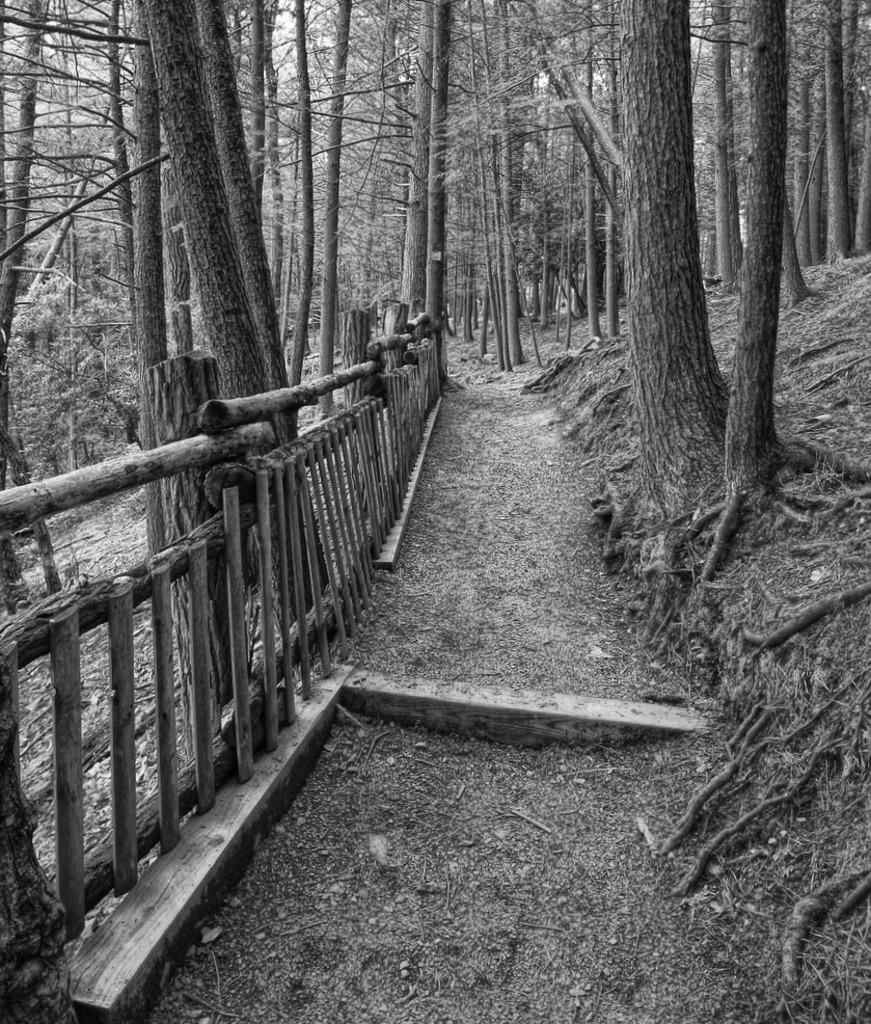What is the color scheme of the image? The image is black and white and white. What type of natural elements can be seen in the image? There are trees in the image. Where is the tree trunk located in the image? The tree trunk is on the left side of the image. What type of structure is present on the left side of the image? There is a wooden fence on the left side of the image. How many cakes are displayed on the wooden fence in the image? There are no cakes present in the image; it features trees and a wooden fence. Can you tell me the name of the mother in the image? There is no mother or any people present in the image. 